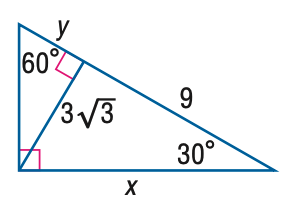Answer the mathemtical geometry problem and directly provide the correct option letter.
Question: Find y.
Choices: A: 3 B: 3 \sqrt { 3 } C: 9 D: 6 \sqrt { 3 } A 